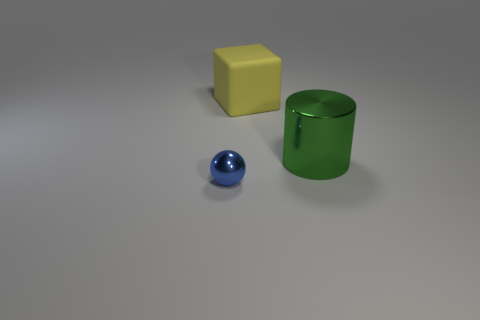Add 1 tiny gray cubes. How many objects exist? 4 Subtract all cylinders. How many objects are left? 2 Add 1 matte objects. How many matte objects are left? 2 Add 3 small blue metal objects. How many small blue metal objects exist? 4 Subtract 0 purple blocks. How many objects are left? 3 Subtract all shiny cylinders. Subtract all green cylinders. How many objects are left? 1 